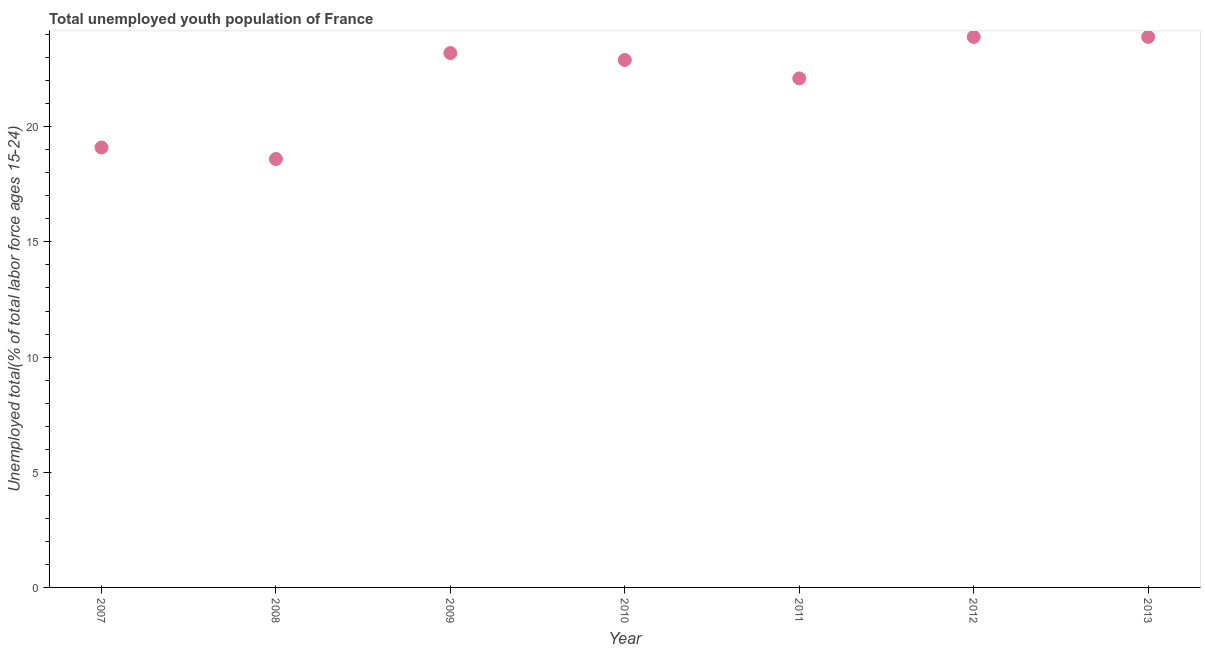What is the unemployed youth in 2007?
Offer a terse response. 19.1. Across all years, what is the maximum unemployed youth?
Offer a terse response. 23.9. Across all years, what is the minimum unemployed youth?
Provide a short and direct response. 18.6. In which year was the unemployed youth maximum?
Offer a very short reply. 2012. In which year was the unemployed youth minimum?
Provide a short and direct response. 2008. What is the sum of the unemployed youth?
Offer a very short reply. 153.7. What is the difference between the unemployed youth in 2007 and 2009?
Ensure brevity in your answer.  -4.1. What is the average unemployed youth per year?
Offer a terse response. 21.96. What is the median unemployed youth?
Your response must be concise. 22.9. Do a majority of the years between 2013 and 2008 (inclusive) have unemployed youth greater than 5 %?
Provide a succinct answer. Yes. What is the ratio of the unemployed youth in 2007 to that in 2012?
Give a very brief answer. 0.8. Is the sum of the unemployed youth in 2008 and 2012 greater than the maximum unemployed youth across all years?
Provide a short and direct response. Yes. What is the difference between the highest and the lowest unemployed youth?
Offer a very short reply. 5.3. Does the unemployed youth monotonically increase over the years?
Offer a terse response. No. How many dotlines are there?
Offer a terse response. 1. How many years are there in the graph?
Provide a succinct answer. 7. What is the difference between two consecutive major ticks on the Y-axis?
Ensure brevity in your answer.  5. Are the values on the major ticks of Y-axis written in scientific E-notation?
Keep it short and to the point. No. What is the title of the graph?
Ensure brevity in your answer.  Total unemployed youth population of France. What is the label or title of the X-axis?
Ensure brevity in your answer.  Year. What is the label or title of the Y-axis?
Provide a short and direct response. Unemployed total(% of total labor force ages 15-24). What is the Unemployed total(% of total labor force ages 15-24) in 2007?
Your answer should be compact. 19.1. What is the Unemployed total(% of total labor force ages 15-24) in 2008?
Offer a very short reply. 18.6. What is the Unemployed total(% of total labor force ages 15-24) in 2009?
Provide a short and direct response. 23.2. What is the Unemployed total(% of total labor force ages 15-24) in 2010?
Your answer should be compact. 22.9. What is the Unemployed total(% of total labor force ages 15-24) in 2011?
Give a very brief answer. 22.1. What is the Unemployed total(% of total labor force ages 15-24) in 2012?
Your answer should be compact. 23.9. What is the Unemployed total(% of total labor force ages 15-24) in 2013?
Make the answer very short. 23.9. What is the difference between the Unemployed total(% of total labor force ages 15-24) in 2007 and 2008?
Offer a terse response. 0.5. What is the difference between the Unemployed total(% of total labor force ages 15-24) in 2007 and 2011?
Give a very brief answer. -3. What is the difference between the Unemployed total(% of total labor force ages 15-24) in 2008 and 2011?
Give a very brief answer. -3.5. What is the difference between the Unemployed total(% of total labor force ages 15-24) in 2008 and 2012?
Ensure brevity in your answer.  -5.3. What is the difference between the Unemployed total(% of total labor force ages 15-24) in 2008 and 2013?
Keep it short and to the point. -5.3. What is the difference between the Unemployed total(% of total labor force ages 15-24) in 2009 and 2011?
Provide a short and direct response. 1.1. What is the difference between the Unemployed total(% of total labor force ages 15-24) in 2009 and 2013?
Offer a very short reply. -0.7. What is the difference between the Unemployed total(% of total labor force ages 15-24) in 2010 and 2012?
Your response must be concise. -1. What is the difference between the Unemployed total(% of total labor force ages 15-24) in 2012 and 2013?
Your answer should be compact. 0. What is the ratio of the Unemployed total(% of total labor force ages 15-24) in 2007 to that in 2008?
Ensure brevity in your answer.  1.03. What is the ratio of the Unemployed total(% of total labor force ages 15-24) in 2007 to that in 2009?
Give a very brief answer. 0.82. What is the ratio of the Unemployed total(% of total labor force ages 15-24) in 2007 to that in 2010?
Your answer should be compact. 0.83. What is the ratio of the Unemployed total(% of total labor force ages 15-24) in 2007 to that in 2011?
Your answer should be very brief. 0.86. What is the ratio of the Unemployed total(% of total labor force ages 15-24) in 2007 to that in 2012?
Offer a terse response. 0.8. What is the ratio of the Unemployed total(% of total labor force ages 15-24) in 2007 to that in 2013?
Your answer should be very brief. 0.8. What is the ratio of the Unemployed total(% of total labor force ages 15-24) in 2008 to that in 2009?
Keep it short and to the point. 0.8. What is the ratio of the Unemployed total(% of total labor force ages 15-24) in 2008 to that in 2010?
Your answer should be compact. 0.81. What is the ratio of the Unemployed total(% of total labor force ages 15-24) in 2008 to that in 2011?
Ensure brevity in your answer.  0.84. What is the ratio of the Unemployed total(% of total labor force ages 15-24) in 2008 to that in 2012?
Your answer should be compact. 0.78. What is the ratio of the Unemployed total(% of total labor force ages 15-24) in 2008 to that in 2013?
Provide a succinct answer. 0.78. What is the ratio of the Unemployed total(% of total labor force ages 15-24) in 2009 to that in 2010?
Offer a very short reply. 1.01. What is the ratio of the Unemployed total(% of total labor force ages 15-24) in 2009 to that in 2011?
Give a very brief answer. 1.05. What is the ratio of the Unemployed total(% of total labor force ages 15-24) in 2009 to that in 2012?
Keep it short and to the point. 0.97. What is the ratio of the Unemployed total(% of total labor force ages 15-24) in 2010 to that in 2011?
Provide a short and direct response. 1.04. What is the ratio of the Unemployed total(% of total labor force ages 15-24) in 2010 to that in 2012?
Offer a terse response. 0.96. What is the ratio of the Unemployed total(% of total labor force ages 15-24) in 2010 to that in 2013?
Make the answer very short. 0.96. What is the ratio of the Unemployed total(% of total labor force ages 15-24) in 2011 to that in 2012?
Keep it short and to the point. 0.93. What is the ratio of the Unemployed total(% of total labor force ages 15-24) in 2011 to that in 2013?
Ensure brevity in your answer.  0.93. What is the ratio of the Unemployed total(% of total labor force ages 15-24) in 2012 to that in 2013?
Provide a succinct answer. 1. 